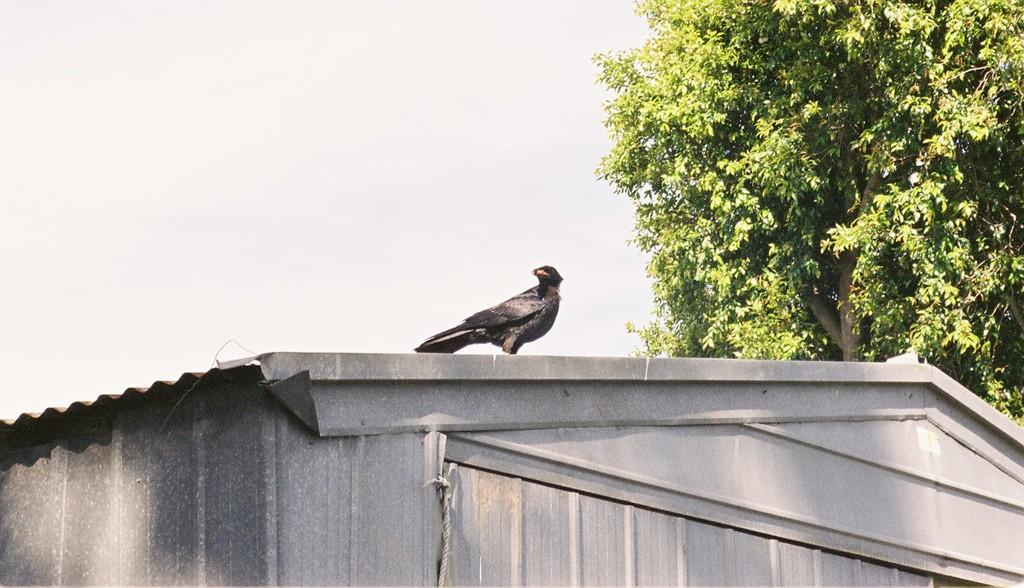What is located on the shed in the center of the image? There is a bird on the shed in the center of the image. What type of vegetation is on the right side of the image? There is a tree on the right side of the image. What is visible at the top of the image? The sky is visible at the top of the image. Can you touch the quicksand in the image? There is no quicksand present in the image. How many chickens are visible in the image? There are no chickens present in the image. 